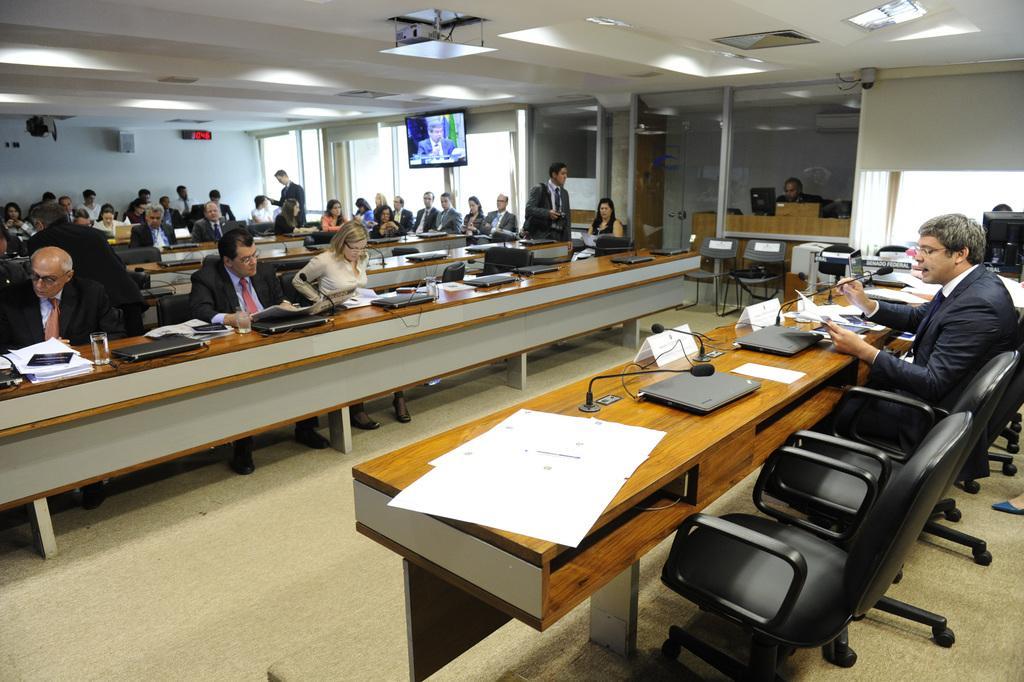Could you give a brief overview of what you see in this image? In this image there is a room with a television attached to the wall and a projector attached to the ceiling and a digital clock and here are some group of people sitting in the chair and here also some group of people who are sitting and there are some papers, a microphone ,laptop,name board and some papers and files in the table and the man is talking in the microphone. 